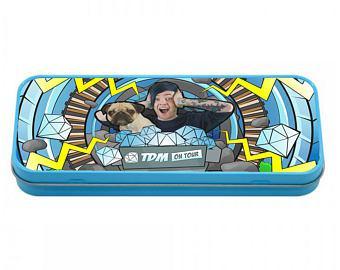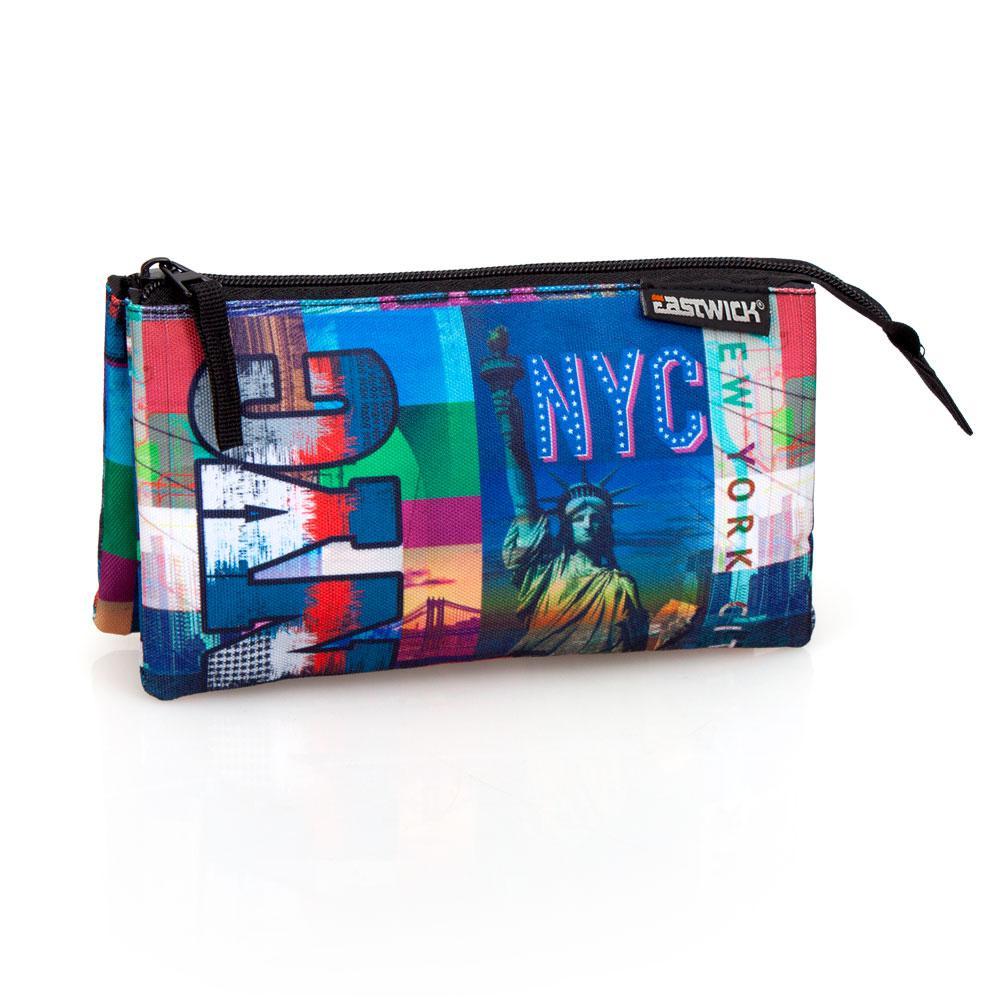The first image is the image on the left, the second image is the image on the right. Given the left and right images, does the statement "There are only two pencil cases, and both are closed." hold true? Answer yes or no. Yes. The first image is the image on the left, the second image is the image on the right. For the images displayed, is the sentence "Each image shows a single closed case, and all cases feature blue in their color scheme." factually correct? Answer yes or no. Yes. 